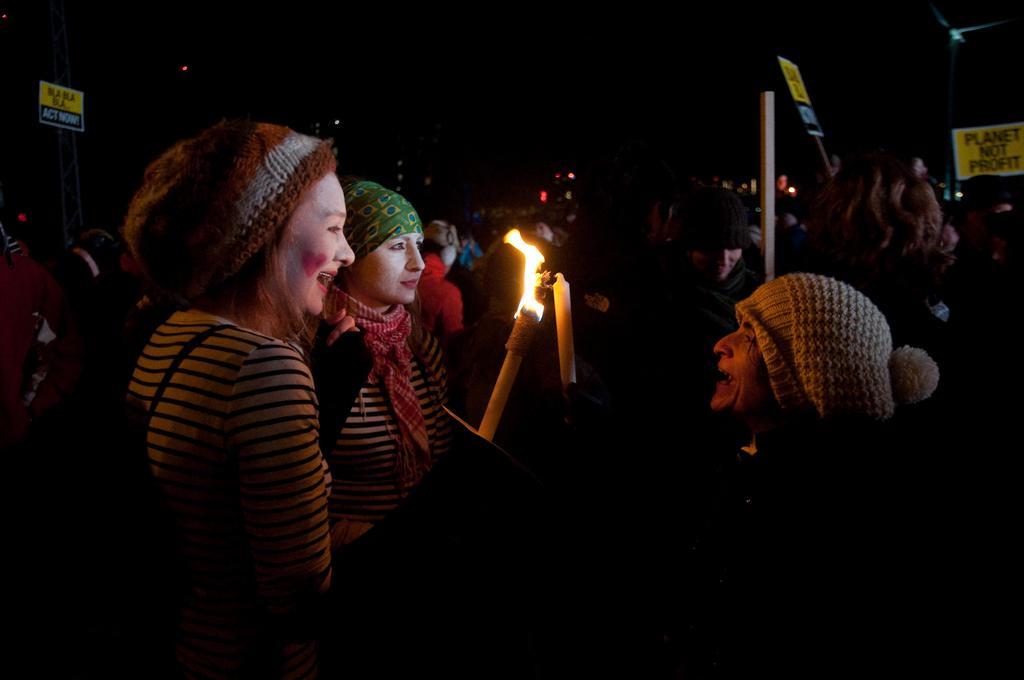Describe this image in one or two sentences. This is an image clicked in the dark. Here I can see three persons wearing caps on the heads, holding two candles and smiling. In the background I can see some more people in the dark. 